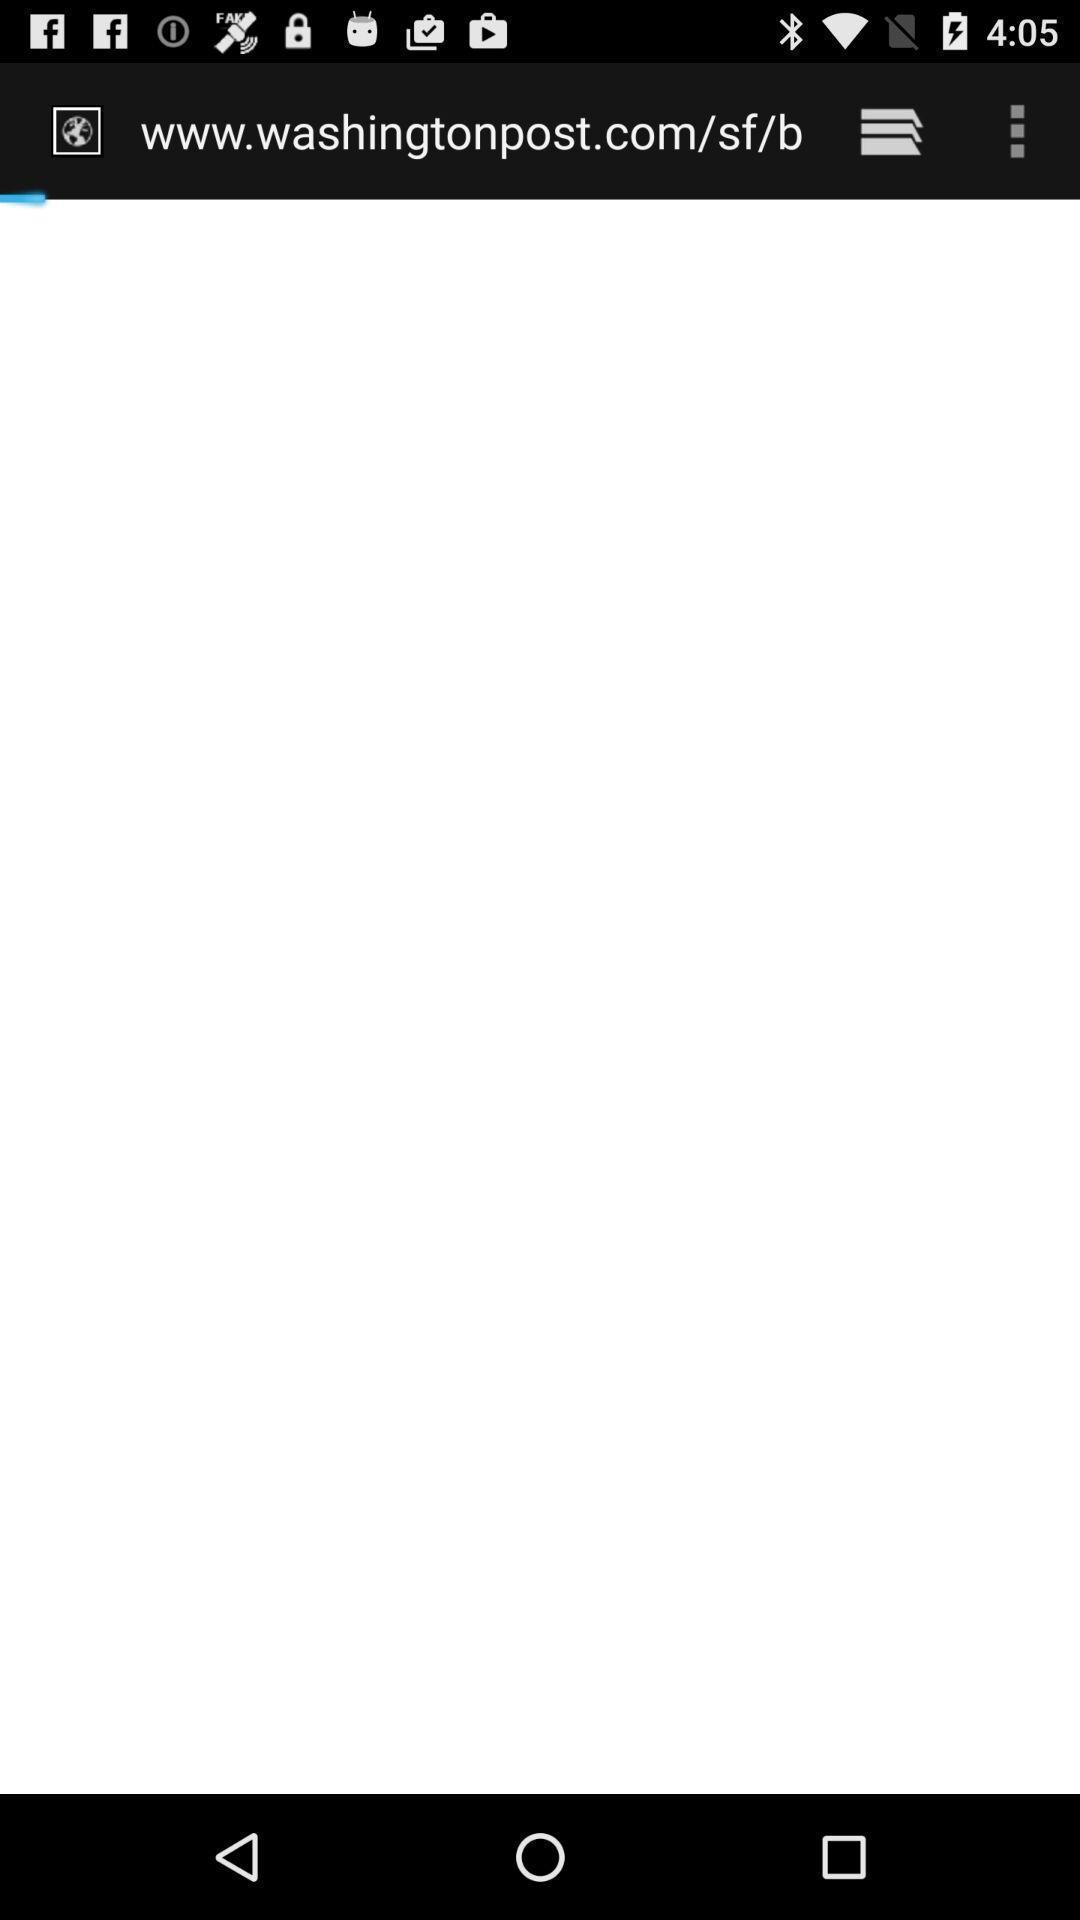Please provide a description for this image. Screen showing loading page of a browser application. 